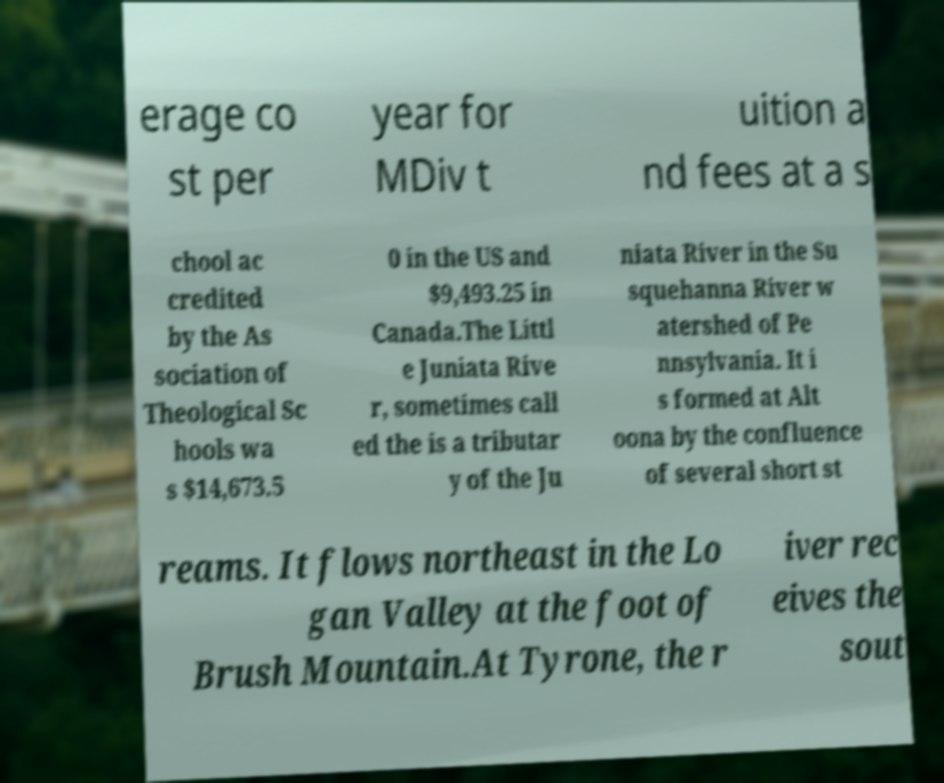There's text embedded in this image that I need extracted. Can you transcribe it verbatim? erage co st per year for MDiv t uition a nd fees at a s chool ac credited by the As sociation of Theological Sc hools wa s $14,673.5 0 in the US and $9,493.25 in Canada.The Littl e Juniata Rive r, sometimes call ed the is a tributar y of the Ju niata River in the Su squehanna River w atershed of Pe nnsylvania. It i s formed at Alt oona by the confluence of several short st reams. It flows northeast in the Lo gan Valley at the foot of Brush Mountain.At Tyrone, the r iver rec eives the sout 